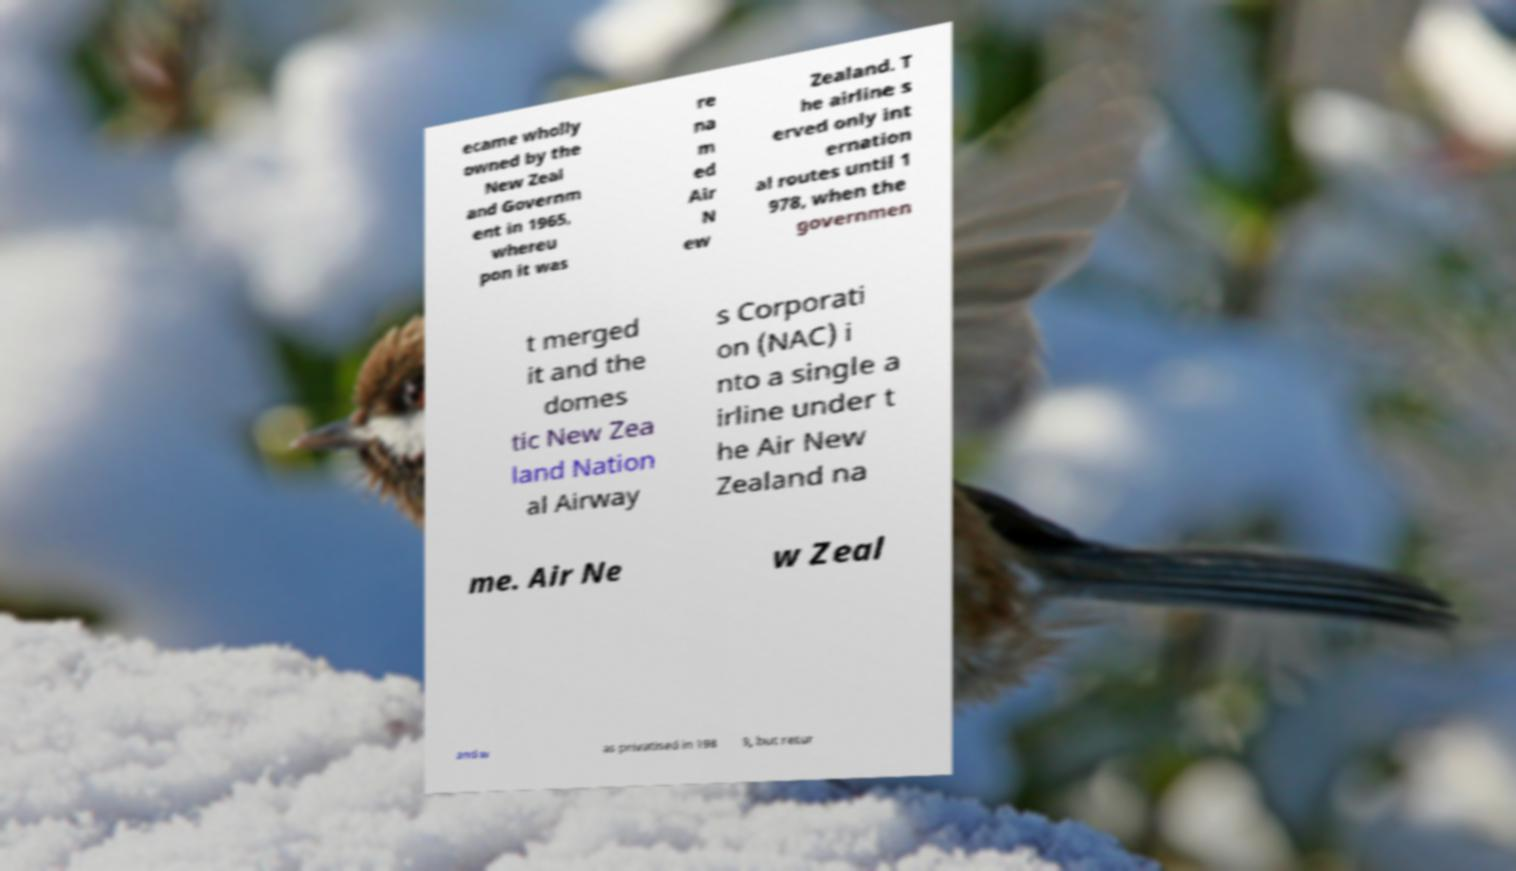What messages or text are displayed in this image? I need them in a readable, typed format. ecame wholly owned by the New Zeal and Governm ent in 1965, whereu pon it was re na m ed Air N ew Zealand. T he airline s erved only int ernation al routes until 1 978, when the governmen t merged it and the domes tic New Zea land Nation al Airway s Corporati on (NAC) i nto a single a irline under t he Air New Zealand na me. Air Ne w Zeal and w as privatised in 198 9, but retur 